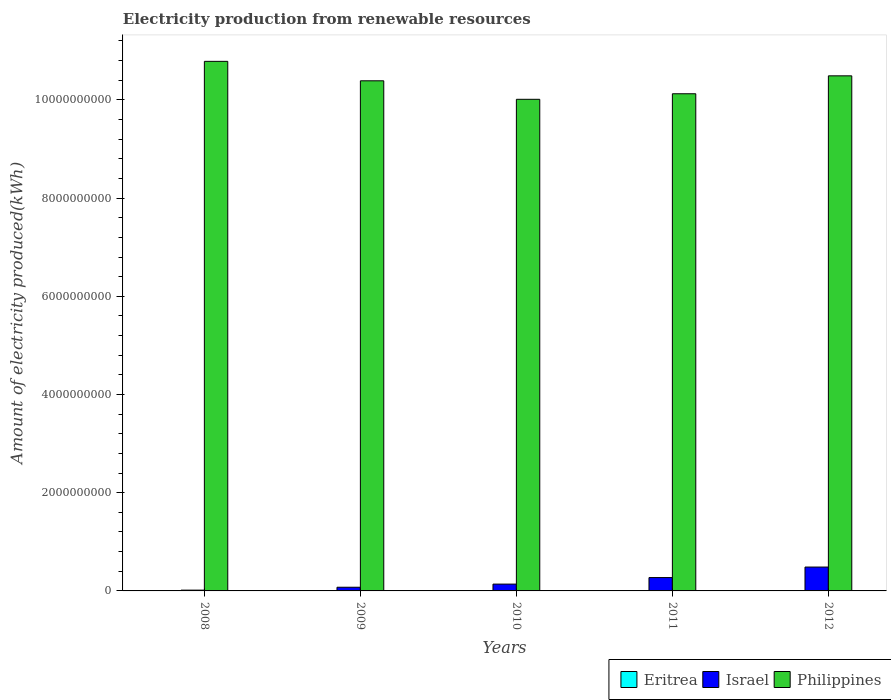How many different coloured bars are there?
Make the answer very short. 3. How many groups of bars are there?
Offer a very short reply. 5. Are the number of bars per tick equal to the number of legend labels?
Your answer should be compact. Yes. How many bars are there on the 3rd tick from the left?
Offer a very short reply. 3. What is the amount of electricity produced in Eritrea in 2011?
Offer a terse response. 2.00e+06. Across all years, what is the maximum amount of electricity produced in Israel?
Your answer should be very brief. 4.86e+08. Across all years, what is the minimum amount of electricity produced in Israel?
Your answer should be very brief. 1.60e+07. In which year was the amount of electricity produced in Eritrea minimum?
Provide a succinct answer. 2008. What is the total amount of electricity produced in Eritrea in the graph?
Offer a very short reply. 1.00e+07. What is the difference between the amount of electricity produced in Eritrea in 2008 and that in 2011?
Offer a very short reply. 0. What is the difference between the amount of electricity produced in Philippines in 2011 and the amount of electricity produced in Eritrea in 2009?
Make the answer very short. 1.01e+1. What is the average amount of electricity produced in Eritrea per year?
Provide a succinct answer. 2.00e+06. In the year 2010, what is the difference between the amount of electricity produced in Philippines and amount of electricity produced in Eritrea?
Your answer should be very brief. 1.00e+1. What is the ratio of the amount of electricity produced in Israel in 2009 to that in 2012?
Your answer should be compact. 0.15. Is the amount of electricity produced in Eritrea in 2008 less than that in 2012?
Offer a very short reply. No. Is the difference between the amount of electricity produced in Philippines in 2008 and 2012 greater than the difference between the amount of electricity produced in Eritrea in 2008 and 2012?
Offer a terse response. Yes. What is the difference between the highest and the second highest amount of electricity produced in Philippines?
Make the answer very short. 2.95e+08. What is the difference between the highest and the lowest amount of electricity produced in Israel?
Your answer should be very brief. 4.70e+08. What does the 2nd bar from the left in 2012 represents?
Make the answer very short. Israel. What does the 2nd bar from the right in 2010 represents?
Ensure brevity in your answer.  Israel. Is it the case that in every year, the sum of the amount of electricity produced in Israel and amount of electricity produced in Eritrea is greater than the amount of electricity produced in Philippines?
Your response must be concise. No. What is the difference between two consecutive major ticks on the Y-axis?
Ensure brevity in your answer.  2.00e+09. Does the graph contain any zero values?
Offer a terse response. No. Does the graph contain grids?
Your answer should be very brief. No. How are the legend labels stacked?
Your answer should be very brief. Horizontal. What is the title of the graph?
Offer a very short reply. Electricity production from renewable resources. What is the label or title of the X-axis?
Offer a terse response. Years. What is the label or title of the Y-axis?
Ensure brevity in your answer.  Amount of electricity produced(kWh). What is the Amount of electricity produced(kWh) of Israel in 2008?
Offer a very short reply. 1.60e+07. What is the Amount of electricity produced(kWh) in Philippines in 2008?
Keep it short and to the point. 1.08e+1. What is the Amount of electricity produced(kWh) of Eritrea in 2009?
Ensure brevity in your answer.  2.00e+06. What is the Amount of electricity produced(kWh) of Israel in 2009?
Provide a short and direct response. 7.50e+07. What is the Amount of electricity produced(kWh) of Philippines in 2009?
Provide a short and direct response. 1.04e+1. What is the Amount of electricity produced(kWh) in Eritrea in 2010?
Give a very brief answer. 2.00e+06. What is the Amount of electricity produced(kWh) in Israel in 2010?
Provide a succinct answer. 1.39e+08. What is the Amount of electricity produced(kWh) of Philippines in 2010?
Your answer should be compact. 1.00e+1. What is the Amount of electricity produced(kWh) in Eritrea in 2011?
Your response must be concise. 2.00e+06. What is the Amount of electricity produced(kWh) in Israel in 2011?
Offer a very short reply. 2.72e+08. What is the Amount of electricity produced(kWh) in Philippines in 2011?
Ensure brevity in your answer.  1.01e+1. What is the Amount of electricity produced(kWh) of Eritrea in 2012?
Your answer should be compact. 2.00e+06. What is the Amount of electricity produced(kWh) of Israel in 2012?
Your answer should be very brief. 4.86e+08. What is the Amount of electricity produced(kWh) in Philippines in 2012?
Keep it short and to the point. 1.05e+1. Across all years, what is the maximum Amount of electricity produced(kWh) of Israel?
Your answer should be compact. 4.86e+08. Across all years, what is the maximum Amount of electricity produced(kWh) of Philippines?
Ensure brevity in your answer.  1.08e+1. Across all years, what is the minimum Amount of electricity produced(kWh) of Israel?
Your answer should be very brief. 1.60e+07. Across all years, what is the minimum Amount of electricity produced(kWh) of Philippines?
Give a very brief answer. 1.00e+1. What is the total Amount of electricity produced(kWh) in Israel in the graph?
Keep it short and to the point. 9.88e+08. What is the total Amount of electricity produced(kWh) of Philippines in the graph?
Provide a short and direct response. 5.18e+1. What is the difference between the Amount of electricity produced(kWh) in Eritrea in 2008 and that in 2009?
Keep it short and to the point. 0. What is the difference between the Amount of electricity produced(kWh) in Israel in 2008 and that in 2009?
Keep it short and to the point. -5.90e+07. What is the difference between the Amount of electricity produced(kWh) of Philippines in 2008 and that in 2009?
Give a very brief answer. 3.96e+08. What is the difference between the Amount of electricity produced(kWh) of Israel in 2008 and that in 2010?
Your answer should be compact. -1.23e+08. What is the difference between the Amount of electricity produced(kWh) in Philippines in 2008 and that in 2010?
Keep it short and to the point. 7.73e+08. What is the difference between the Amount of electricity produced(kWh) in Eritrea in 2008 and that in 2011?
Offer a terse response. 0. What is the difference between the Amount of electricity produced(kWh) of Israel in 2008 and that in 2011?
Offer a terse response. -2.56e+08. What is the difference between the Amount of electricity produced(kWh) of Philippines in 2008 and that in 2011?
Your answer should be compact. 6.60e+08. What is the difference between the Amount of electricity produced(kWh) of Israel in 2008 and that in 2012?
Offer a terse response. -4.70e+08. What is the difference between the Amount of electricity produced(kWh) of Philippines in 2008 and that in 2012?
Offer a terse response. 2.95e+08. What is the difference between the Amount of electricity produced(kWh) in Eritrea in 2009 and that in 2010?
Keep it short and to the point. 0. What is the difference between the Amount of electricity produced(kWh) in Israel in 2009 and that in 2010?
Keep it short and to the point. -6.40e+07. What is the difference between the Amount of electricity produced(kWh) in Philippines in 2009 and that in 2010?
Give a very brief answer. 3.77e+08. What is the difference between the Amount of electricity produced(kWh) in Israel in 2009 and that in 2011?
Your response must be concise. -1.97e+08. What is the difference between the Amount of electricity produced(kWh) of Philippines in 2009 and that in 2011?
Offer a terse response. 2.64e+08. What is the difference between the Amount of electricity produced(kWh) of Eritrea in 2009 and that in 2012?
Ensure brevity in your answer.  0. What is the difference between the Amount of electricity produced(kWh) of Israel in 2009 and that in 2012?
Ensure brevity in your answer.  -4.11e+08. What is the difference between the Amount of electricity produced(kWh) in Philippines in 2009 and that in 2012?
Ensure brevity in your answer.  -1.01e+08. What is the difference between the Amount of electricity produced(kWh) in Israel in 2010 and that in 2011?
Ensure brevity in your answer.  -1.33e+08. What is the difference between the Amount of electricity produced(kWh) in Philippines in 2010 and that in 2011?
Offer a terse response. -1.13e+08. What is the difference between the Amount of electricity produced(kWh) in Eritrea in 2010 and that in 2012?
Offer a terse response. 0. What is the difference between the Amount of electricity produced(kWh) of Israel in 2010 and that in 2012?
Ensure brevity in your answer.  -3.47e+08. What is the difference between the Amount of electricity produced(kWh) of Philippines in 2010 and that in 2012?
Offer a very short reply. -4.78e+08. What is the difference between the Amount of electricity produced(kWh) of Eritrea in 2011 and that in 2012?
Keep it short and to the point. 0. What is the difference between the Amount of electricity produced(kWh) of Israel in 2011 and that in 2012?
Give a very brief answer. -2.14e+08. What is the difference between the Amount of electricity produced(kWh) in Philippines in 2011 and that in 2012?
Offer a very short reply. -3.65e+08. What is the difference between the Amount of electricity produced(kWh) of Eritrea in 2008 and the Amount of electricity produced(kWh) of Israel in 2009?
Offer a very short reply. -7.30e+07. What is the difference between the Amount of electricity produced(kWh) in Eritrea in 2008 and the Amount of electricity produced(kWh) in Philippines in 2009?
Give a very brief answer. -1.04e+1. What is the difference between the Amount of electricity produced(kWh) in Israel in 2008 and the Amount of electricity produced(kWh) in Philippines in 2009?
Your response must be concise. -1.04e+1. What is the difference between the Amount of electricity produced(kWh) in Eritrea in 2008 and the Amount of electricity produced(kWh) in Israel in 2010?
Your response must be concise. -1.37e+08. What is the difference between the Amount of electricity produced(kWh) in Eritrea in 2008 and the Amount of electricity produced(kWh) in Philippines in 2010?
Ensure brevity in your answer.  -1.00e+1. What is the difference between the Amount of electricity produced(kWh) in Israel in 2008 and the Amount of electricity produced(kWh) in Philippines in 2010?
Make the answer very short. -1.00e+1. What is the difference between the Amount of electricity produced(kWh) in Eritrea in 2008 and the Amount of electricity produced(kWh) in Israel in 2011?
Provide a short and direct response. -2.70e+08. What is the difference between the Amount of electricity produced(kWh) in Eritrea in 2008 and the Amount of electricity produced(kWh) in Philippines in 2011?
Your answer should be very brief. -1.01e+1. What is the difference between the Amount of electricity produced(kWh) in Israel in 2008 and the Amount of electricity produced(kWh) in Philippines in 2011?
Keep it short and to the point. -1.01e+1. What is the difference between the Amount of electricity produced(kWh) in Eritrea in 2008 and the Amount of electricity produced(kWh) in Israel in 2012?
Ensure brevity in your answer.  -4.84e+08. What is the difference between the Amount of electricity produced(kWh) of Eritrea in 2008 and the Amount of electricity produced(kWh) of Philippines in 2012?
Your answer should be very brief. -1.05e+1. What is the difference between the Amount of electricity produced(kWh) of Israel in 2008 and the Amount of electricity produced(kWh) of Philippines in 2012?
Keep it short and to the point. -1.05e+1. What is the difference between the Amount of electricity produced(kWh) of Eritrea in 2009 and the Amount of electricity produced(kWh) of Israel in 2010?
Offer a terse response. -1.37e+08. What is the difference between the Amount of electricity produced(kWh) in Eritrea in 2009 and the Amount of electricity produced(kWh) in Philippines in 2010?
Your response must be concise. -1.00e+1. What is the difference between the Amount of electricity produced(kWh) of Israel in 2009 and the Amount of electricity produced(kWh) of Philippines in 2010?
Your answer should be compact. -9.94e+09. What is the difference between the Amount of electricity produced(kWh) of Eritrea in 2009 and the Amount of electricity produced(kWh) of Israel in 2011?
Give a very brief answer. -2.70e+08. What is the difference between the Amount of electricity produced(kWh) of Eritrea in 2009 and the Amount of electricity produced(kWh) of Philippines in 2011?
Offer a very short reply. -1.01e+1. What is the difference between the Amount of electricity produced(kWh) of Israel in 2009 and the Amount of electricity produced(kWh) of Philippines in 2011?
Ensure brevity in your answer.  -1.00e+1. What is the difference between the Amount of electricity produced(kWh) in Eritrea in 2009 and the Amount of electricity produced(kWh) in Israel in 2012?
Provide a succinct answer. -4.84e+08. What is the difference between the Amount of electricity produced(kWh) of Eritrea in 2009 and the Amount of electricity produced(kWh) of Philippines in 2012?
Your answer should be compact. -1.05e+1. What is the difference between the Amount of electricity produced(kWh) of Israel in 2009 and the Amount of electricity produced(kWh) of Philippines in 2012?
Provide a short and direct response. -1.04e+1. What is the difference between the Amount of electricity produced(kWh) in Eritrea in 2010 and the Amount of electricity produced(kWh) in Israel in 2011?
Ensure brevity in your answer.  -2.70e+08. What is the difference between the Amount of electricity produced(kWh) of Eritrea in 2010 and the Amount of electricity produced(kWh) of Philippines in 2011?
Ensure brevity in your answer.  -1.01e+1. What is the difference between the Amount of electricity produced(kWh) in Israel in 2010 and the Amount of electricity produced(kWh) in Philippines in 2011?
Provide a short and direct response. -9.99e+09. What is the difference between the Amount of electricity produced(kWh) of Eritrea in 2010 and the Amount of electricity produced(kWh) of Israel in 2012?
Ensure brevity in your answer.  -4.84e+08. What is the difference between the Amount of electricity produced(kWh) of Eritrea in 2010 and the Amount of electricity produced(kWh) of Philippines in 2012?
Keep it short and to the point. -1.05e+1. What is the difference between the Amount of electricity produced(kWh) in Israel in 2010 and the Amount of electricity produced(kWh) in Philippines in 2012?
Keep it short and to the point. -1.04e+1. What is the difference between the Amount of electricity produced(kWh) in Eritrea in 2011 and the Amount of electricity produced(kWh) in Israel in 2012?
Ensure brevity in your answer.  -4.84e+08. What is the difference between the Amount of electricity produced(kWh) in Eritrea in 2011 and the Amount of electricity produced(kWh) in Philippines in 2012?
Your response must be concise. -1.05e+1. What is the difference between the Amount of electricity produced(kWh) of Israel in 2011 and the Amount of electricity produced(kWh) of Philippines in 2012?
Ensure brevity in your answer.  -1.02e+1. What is the average Amount of electricity produced(kWh) of Eritrea per year?
Provide a short and direct response. 2.00e+06. What is the average Amount of electricity produced(kWh) of Israel per year?
Ensure brevity in your answer.  1.98e+08. What is the average Amount of electricity produced(kWh) of Philippines per year?
Ensure brevity in your answer.  1.04e+1. In the year 2008, what is the difference between the Amount of electricity produced(kWh) of Eritrea and Amount of electricity produced(kWh) of Israel?
Ensure brevity in your answer.  -1.40e+07. In the year 2008, what is the difference between the Amount of electricity produced(kWh) in Eritrea and Amount of electricity produced(kWh) in Philippines?
Provide a short and direct response. -1.08e+1. In the year 2008, what is the difference between the Amount of electricity produced(kWh) of Israel and Amount of electricity produced(kWh) of Philippines?
Make the answer very short. -1.08e+1. In the year 2009, what is the difference between the Amount of electricity produced(kWh) in Eritrea and Amount of electricity produced(kWh) in Israel?
Offer a very short reply. -7.30e+07. In the year 2009, what is the difference between the Amount of electricity produced(kWh) in Eritrea and Amount of electricity produced(kWh) in Philippines?
Make the answer very short. -1.04e+1. In the year 2009, what is the difference between the Amount of electricity produced(kWh) in Israel and Amount of electricity produced(kWh) in Philippines?
Make the answer very short. -1.03e+1. In the year 2010, what is the difference between the Amount of electricity produced(kWh) in Eritrea and Amount of electricity produced(kWh) in Israel?
Keep it short and to the point. -1.37e+08. In the year 2010, what is the difference between the Amount of electricity produced(kWh) of Eritrea and Amount of electricity produced(kWh) of Philippines?
Your response must be concise. -1.00e+1. In the year 2010, what is the difference between the Amount of electricity produced(kWh) in Israel and Amount of electricity produced(kWh) in Philippines?
Give a very brief answer. -9.87e+09. In the year 2011, what is the difference between the Amount of electricity produced(kWh) in Eritrea and Amount of electricity produced(kWh) in Israel?
Provide a succinct answer. -2.70e+08. In the year 2011, what is the difference between the Amount of electricity produced(kWh) in Eritrea and Amount of electricity produced(kWh) in Philippines?
Offer a very short reply. -1.01e+1. In the year 2011, what is the difference between the Amount of electricity produced(kWh) in Israel and Amount of electricity produced(kWh) in Philippines?
Provide a short and direct response. -9.85e+09. In the year 2012, what is the difference between the Amount of electricity produced(kWh) in Eritrea and Amount of electricity produced(kWh) in Israel?
Your answer should be very brief. -4.84e+08. In the year 2012, what is the difference between the Amount of electricity produced(kWh) in Eritrea and Amount of electricity produced(kWh) in Philippines?
Offer a very short reply. -1.05e+1. In the year 2012, what is the difference between the Amount of electricity produced(kWh) of Israel and Amount of electricity produced(kWh) of Philippines?
Provide a short and direct response. -1.00e+1. What is the ratio of the Amount of electricity produced(kWh) of Eritrea in 2008 to that in 2009?
Your answer should be compact. 1. What is the ratio of the Amount of electricity produced(kWh) in Israel in 2008 to that in 2009?
Make the answer very short. 0.21. What is the ratio of the Amount of electricity produced(kWh) in Philippines in 2008 to that in 2009?
Your response must be concise. 1.04. What is the ratio of the Amount of electricity produced(kWh) in Eritrea in 2008 to that in 2010?
Offer a terse response. 1. What is the ratio of the Amount of electricity produced(kWh) in Israel in 2008 to that in 2010?
Offer a very short reply. 0.12. What is the ratio of the Amount of electricity produced(kWh) in Philippines in 2008 to that in 2010?
Provide a short and direct response. 1.08. What is the ratio of the Amount of electricity produced(kWh) of Israel in 2008 to that in 2011?
Your response must be concise. 0.06. What is the ratio of the Amount of electricity produced(kWh) in Philippines in 2008 to that in 2011?
Offer a very short reply. 1.07. What is the ratio of the Amount of electricity produced(kWh) of Israel in 2008 to that in 2012?
Provide a short and direct response. 0.03. What is the ratio of the Amount of electricity produced(kWh) in Philippines in 2008 to that in 2012?
Offer a terse response. 1.03. What is the ratio of the Amount of electricity produced(kWh) of Eritrea in 2009 to that in 2010?
Give a very brief answer. 1. What is the ratio of the Amount of electricity produced(kWh) in Israel in 2009 to that in 2010?
Your response must be concise. 0.54. What is the ratio of the Amount of electricity produced(kWh) of Philippines in 2009 to that in 2010?
Provide a short and direct response. 1.04. What is the ratio of the Amount of electricity produced(kWh) in Israel in 2009 to that in 2011?
Provide a short and direct response. 0.28. What is the ratio of the Amount of electricity produced(kWh) of Philippines in 2009 to that in 2011?
Provide a succinct answer. 1.03. What is the ratio of the Amount of electricity produced(kWh) in Israel in 2009 to that in 2012?
Give a very brief answer. 0.15. What is the ratio of the Amount of electricity produced(kWh) of Philippines in 2009 to that in 2012?
Keep it short and to the point. 0.99. What is the ratio of the Amount of electricity produced(kWh) in Israel in 2010 to that in 2011?
Ensure brevity in your answer.  0.51. What is the ratio of the Amount of electricity produced(kWh) of Philippines in 2010 to that in 2011?
Your answer should be compact. 0.99. What is the ratio of the Amount of electricity produced(kWh) in Eritrea in 2010 to that in 2012?
Your answer should be compact. 1. What is the ratio of the Amount of electricity produced(kWh) in Israel in 2010 to that in 2012?
Your answer should be compact. 0.29. What is the ratio of the Amount of electricity produced(kWh) in Philippines in 2010 to that in 2012?
Make the answer very short. 0.95. What is the ratio of the Amount of electricity produced(kWh) of Israel in 2011 to that in 2012?
Ensure brevity in your answer.  0.56. What is the ratio of the Amount of electricity produced(kWh) of Philippines in 2011 to that in 2012?
Give a very brief answer. 0.97. What is the difference between the highest and the second highest Amount of electricity produced(kWh) of Israel?
Make the answer very short. 2.14e+08. What is the difference between the highest and the second highest Amount of electricity produced(kWh) in Philippines?
Offer a terse response. 2.95e+08. What is the difference between the highest and the lowest Amount of electricity produced(kWh) of Eritrea?
Your response must be concise. 0. What is the difference between the highest and the lowest Amount of electricity produced(kWh) in Israel?
Ensure brevity in your answer.  4.70e+08. What is the difference between the highest and the lowest Amount of electricity produced(kWh) in Philippines?
Keep it short and to the point. 7.73e+08. 